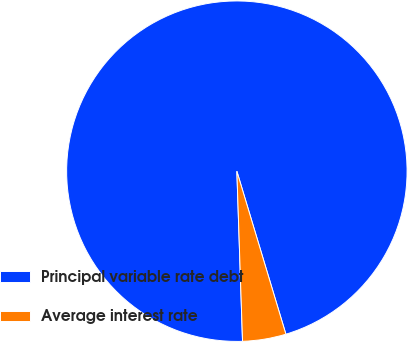Convert chart. <chart><loc_0><loc_0><loc_500><loc_500><pie_chart><fcel>Principal variable rate debt<fcel>Average interest rate<nl><fcel>95.88%<fcel>4.12%<nl></chart> 